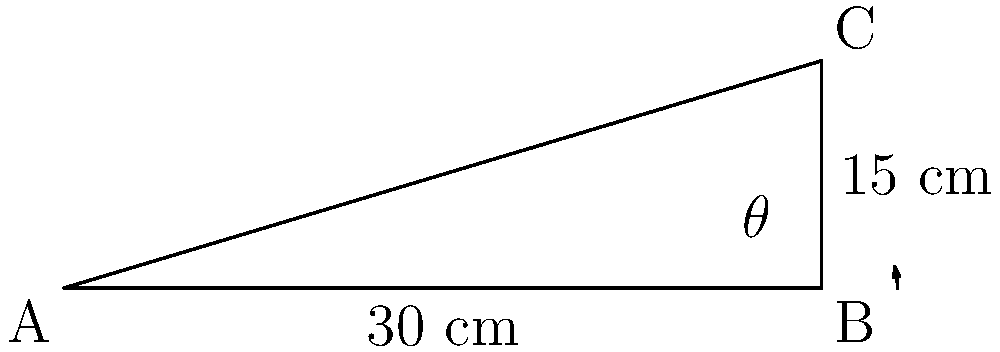In designing a kneeling bench for a church pew, you need to calculate the angle of inclination. The bench is 30 cm long and rises 15 cm from the floor. What is the angle of inclination ($\theta$) for the kneeling bench? To find the angle of inclination, we can use the trigonometric function tangent. Here's how:

1) In the right triangle ABC, we know:
   - The opposite side (rise) = 15 cm
   - The adjacent side (length) = 30 cm

2) The tangent of an angle is defined as the ratio of the opposite side to the adjacent side:

   $$\tan(\theta) = \frac{\text{opposite}}{\text{adjacent}} = \frac{\text{rise}}{\text{length}}$$

3) Substituting our values:

   $$\tan(\theta) = \frac{15}{30} = \frac{1}{2} = 0.5$$

4) To find $\theta$, we need to use the inverse tangent (arctan or $\tan^{-1}$):

   $$\theta = \tan^{-1}(0.5)$$

5) Using a calculator or trigonometric tables:

   $$\theta \approx 26.57°$$

6) Rounding to the nearest degree:

   $$\theta \approx 27°$$

Thus, the angle of inclination for the kneeling bench is approximately 27°.
Answer: $27°$ 